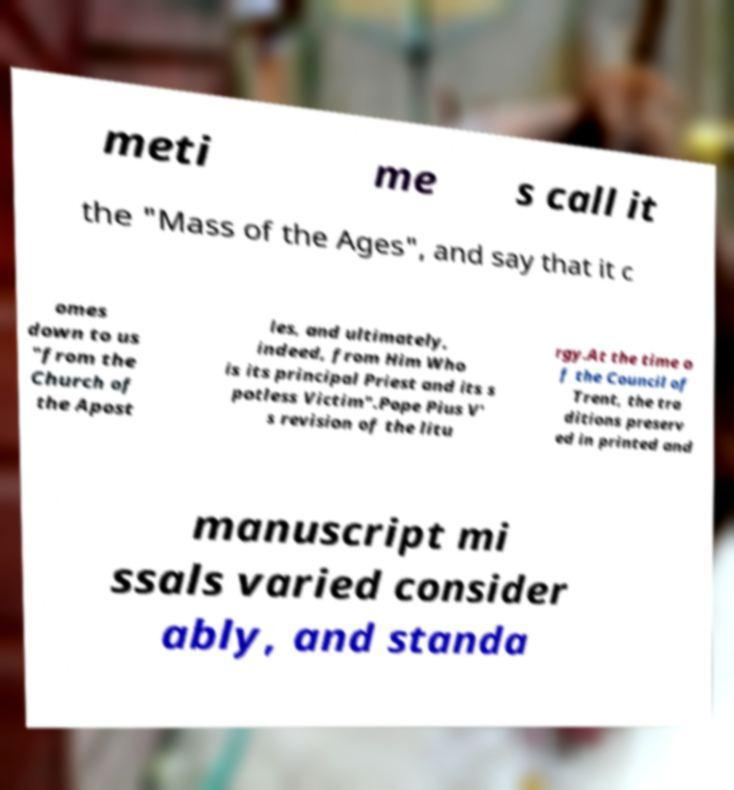Can you accurately transcribe the text from the provided image for me? meti me s call it the "Mass of the Ages", and say that it c omes down to us "from the Church of the Apost les, and ultimately, indeed, from Him Who is its principal Priest and its s potless Victim".Pope Pius V' s revision of the litu rgy.At the time o f the Council of Trent, the tra ditions preserv ed in printed and manuscript mi ssals varied consider ably, and standa 